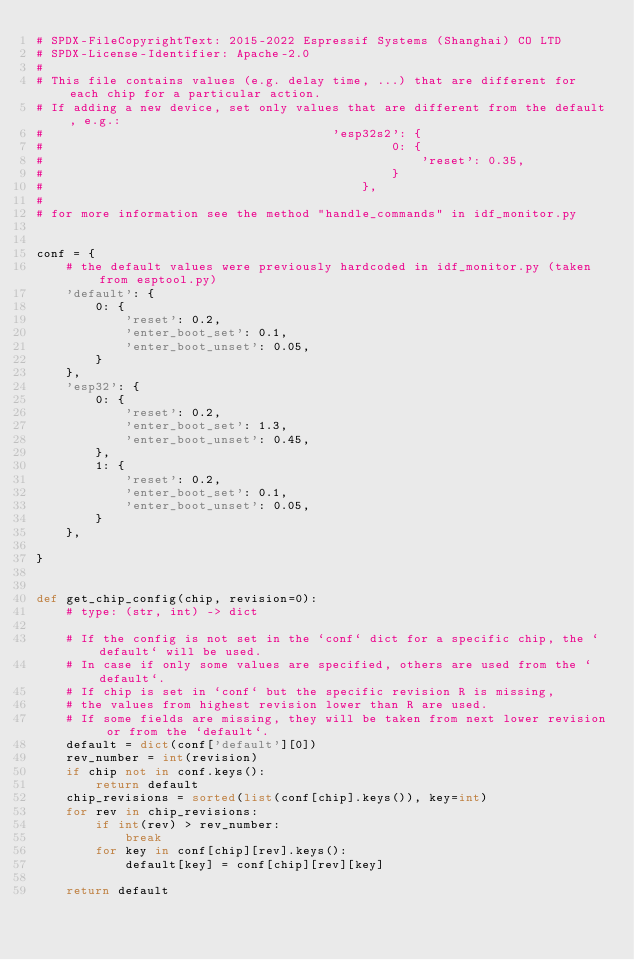<code> <loc_0><loc_0><loc_500><loc_500><_Python_># SPDX-FileCopyrightText: 2015-2022 Espressif Systems (Shanghai) CO LTD
# SPDX-License-Identifier: Apache-2.0
#
# This file contains values (e.g. delay time, ...) that are different for each chip for a particular action.
# If adding a new device, set only values that are different from the default, e.g.:
#                                       'esp32s2': {
#                                               0: {
#                                                   'reset': 0.35,
#                                               }
#                                           },
#
# for more information see the method "handle_commands" in idf_monitor.py


conf = {
    # the default values were previously hardcoded in idf_monitor.py (taken from esptool.py)
    'default': {
        0: {
            'reset': 0.2,
            'enter_boot_set': 0.1,
            'enter_boot_unset': 0.05,
        }
    },
    'esp32': {
        0: {
            'reset': 0.2,
            'enter_boot_set': 1.3,
            'enter_boot_unset': 0.45,
        },
        1: {
            'reset': 0.2,
            'enter_boot_set': 0.1,
            'enter_boot_unset': 0.05,
        }
    },

}


def get_chip_config(chip, revision=0):
    # type: (str, int) -> dict

    # If the config is not set in the `conf` dict for a specific chip, the `default` will be used.
    # In case if only some values are specified, others are used from the `default`.
    # If chip is set in `conf` but the specific revision R is missing,
    # the values from highest revision lower than R are used.
    # If some fields are missing, they will be taken from next lower revision or from the `default`.
    default = dict(conf['default'][0])
    rev_number = int(revision)
    if chip not in conf.keys():
        return default
    chip_revisions = sorted(list(conf[chip].keys()), key=int)
    for rev in chip_revisions:
        if int(rev) > rev_number:
            break
        for key in conf[chip][rev].keys():
            default[key] = conf[chip][rev][key]

    return default
</code> 